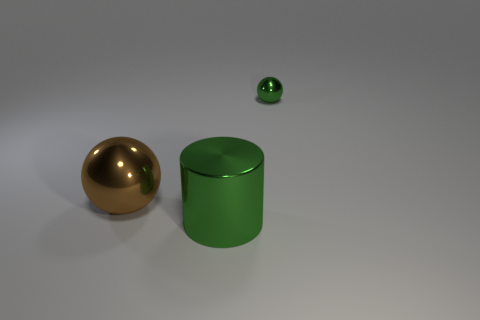What is the shape of the green object behind the metal ball that is in front of the tiny metallic ball that is to the right of the brown thing?
Make the answer very short. Sphere. There is a green object that is the same shape as the brown shiny object; what is its material?
Provide a succinct answer. Metal. How many red rubber cylinders are there?
Keep it short and to the point. 0. There is a green object behind the big green shiny object; what shape is it?
Offer a very short reply. Sphere. What color is the metal sphere that is left of the shiny thing that is to the right of the green thing in front of the brown metal sphere?
Keep it short and to the point. Brown. The other large object that is made of the same material as the brown object is what shape?
Provide a succinct answer. Cylinder. Are there fewer large yellow shiny cylinders than small green shiny objects?
Keep it short and to the point. Yes. Is the material of the green cylinder the same as the tiny green object?
Offer a very short reply. Yes. How many other things are the same color as the metallic cylinder?
Provide a short and direct response. 1. Is the number of blue matte things greater than the number of metal things?
Provide a short and direct response. No. 